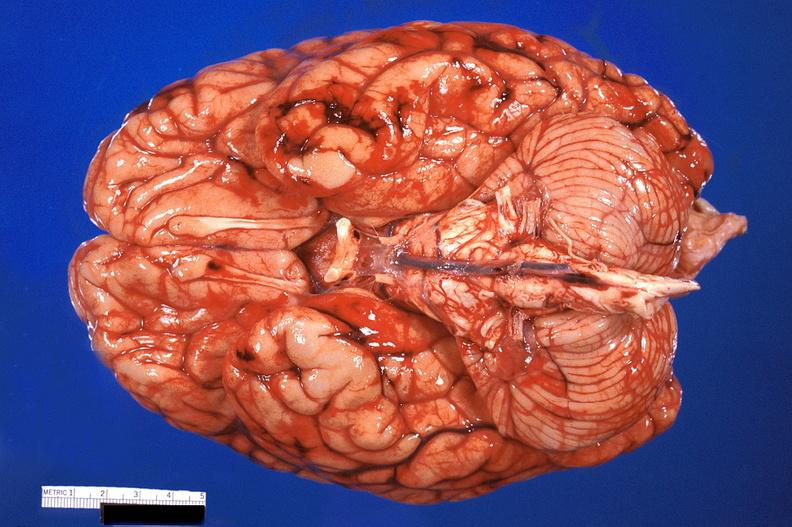why does this image show brain, subarachanoid hemorrhage?
Answer the question using a single word or phrase. Due to disseminated intravascular coagulation 